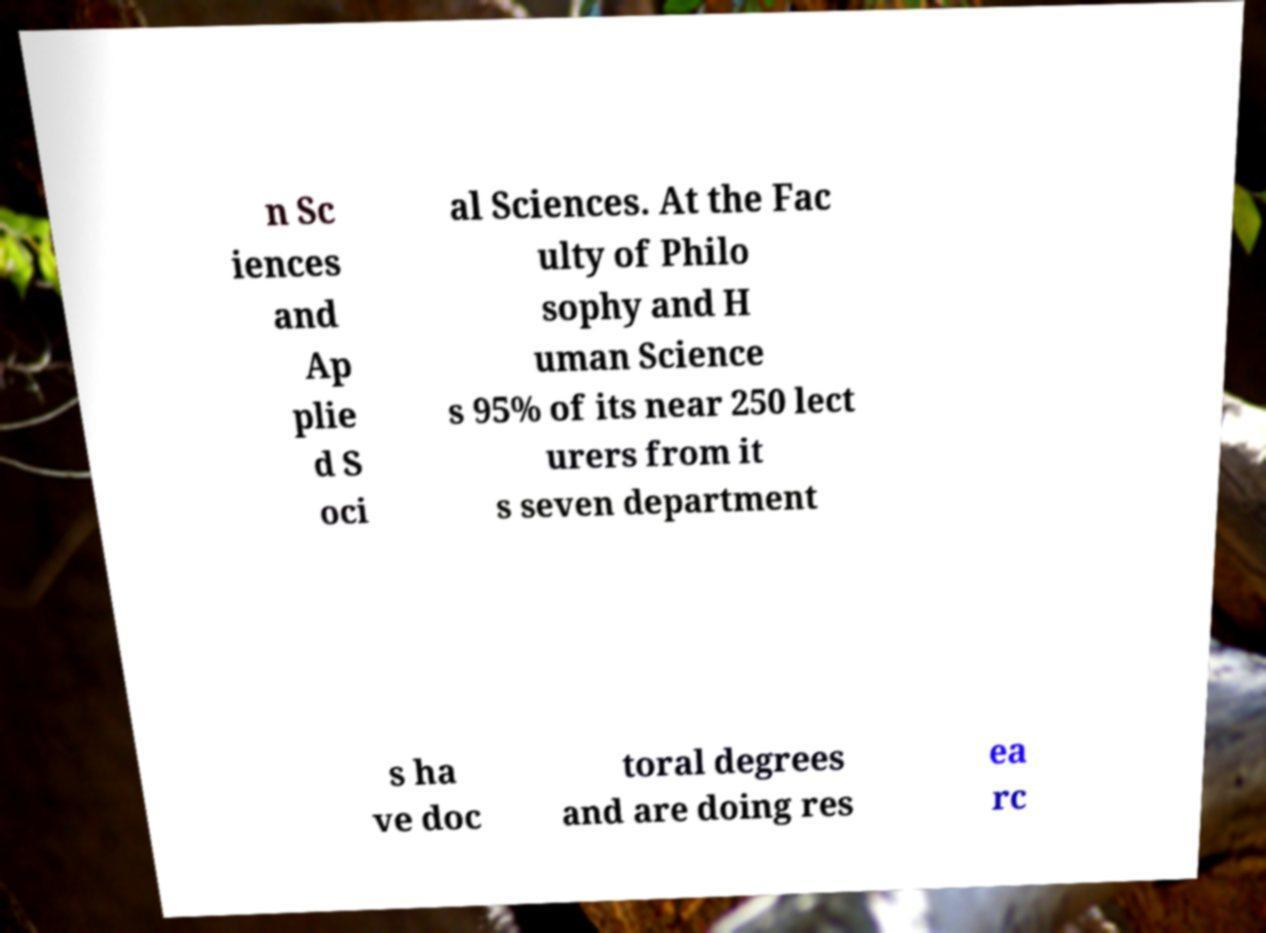For documentation purposes, I need the text within this image transcribed. Could you provide that? n Sc iences and Ap plie d S oci al Sciences. At the Fac ulty of Philo sophy and H uman Science s 95% of its near 250 lect urers from it s seven department s ha ve doc toral degrees and are doing res ea rc 